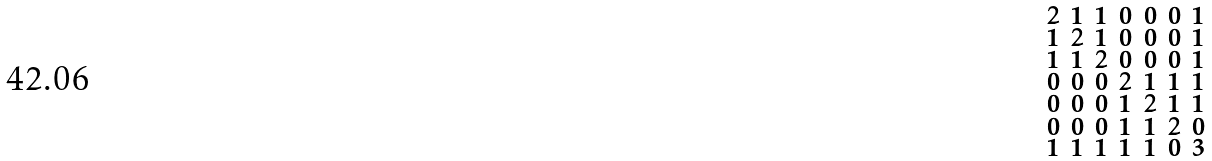Convert formula to latex. <formula><loc_0><loc_0><loc_500><loc_500>\begin{smallmatrix} 2 & 1 & 1 & 0 & 0 & 0 & 1 \\ 1 & 2 & 1 & 0 & 0 & 0 & 1 \\ 1 & 1 & 2 & 0 & 0 & 0 & 1 \\ 0 & 0 & 0 & 2 & 1 & 1 & 1 \\ 0 & 0 & 0 & 1 & 2 & 1 & 1 \\ 0 & 0 & 0 & 1 & 1 & 2 & 0 \\ 1 & 1 & 1 & 1 & 1 & 0 & 3 \end{smallmatrix}</formula> 